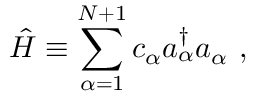Convert formula to latex. <formula><loc_0><loc_0><loc_500><loc_500>\hat { H } \equiv \sum _ { \alpha = 1 } ^ { N + 1 } c _ { \alpha } a _ { \alpha } ^ { \dagger } a _ { \alpha } \ ,</formula> 